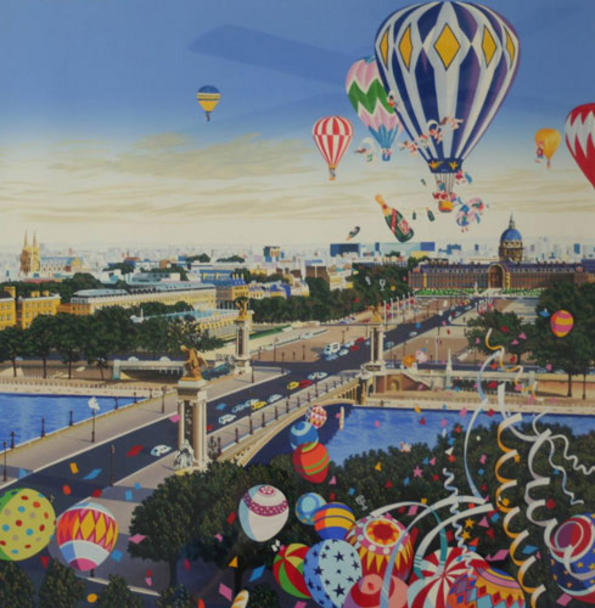Imagine the night-time view of this city. Describe the scene. As night falls upon the whimsical city, it transforms into an enchanted wonderland. The sky, now a deep indigo, is sprinkled with twinkling stars and perhaps even a full moon casting a soft, silvery glow. The hot air balloons, no longer airborne, are tethered and illuminated from within by soft, warm lights, casting a magical glow across the landscape.

The cityscape itself is adorned with twinkling fairy lights and lanterns, highlighting the intricate details of the fantastical architecture. Reflections of these lights dance on the surface of the water, creating a mesmerizing, almost ethereal effect. The streets are filled with the soft hum of activity, as people leisurely stroll and enjoy the enchanting atmosphere.

The night air is filled with the gentle sounds of music and laughter, perhaps from an ongoing festival or celebration. The entire scene is imbued with a sense of peace and wonder, inviting anyone who witnesses it to indulge in the beauty and magic of the moment. 